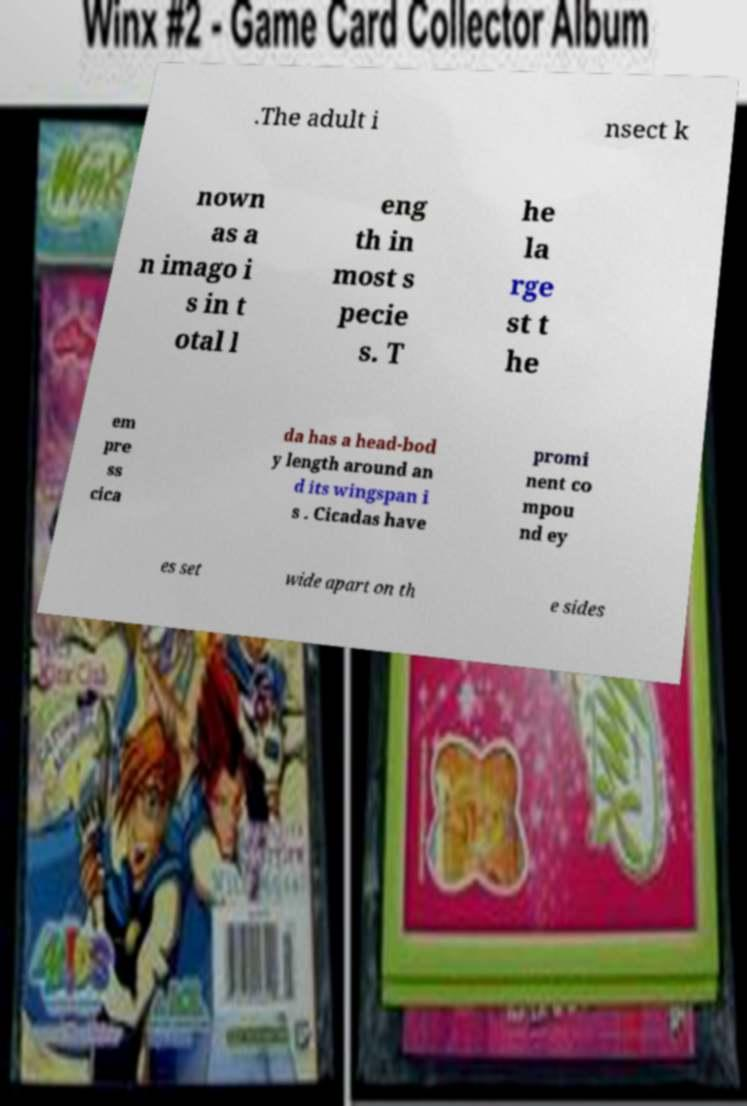Could you assist in decoding the text presented in this image and type it out clearly? .The adult i nsect k nown as a n imago i s in t otal l eng th in most s pecie s. T he la rge st t he em pre ss cica da has a head-bod y length around an d its wingspan i s . Cicadas have promi nent co mpou nd ey es set wide apart on th e sides 